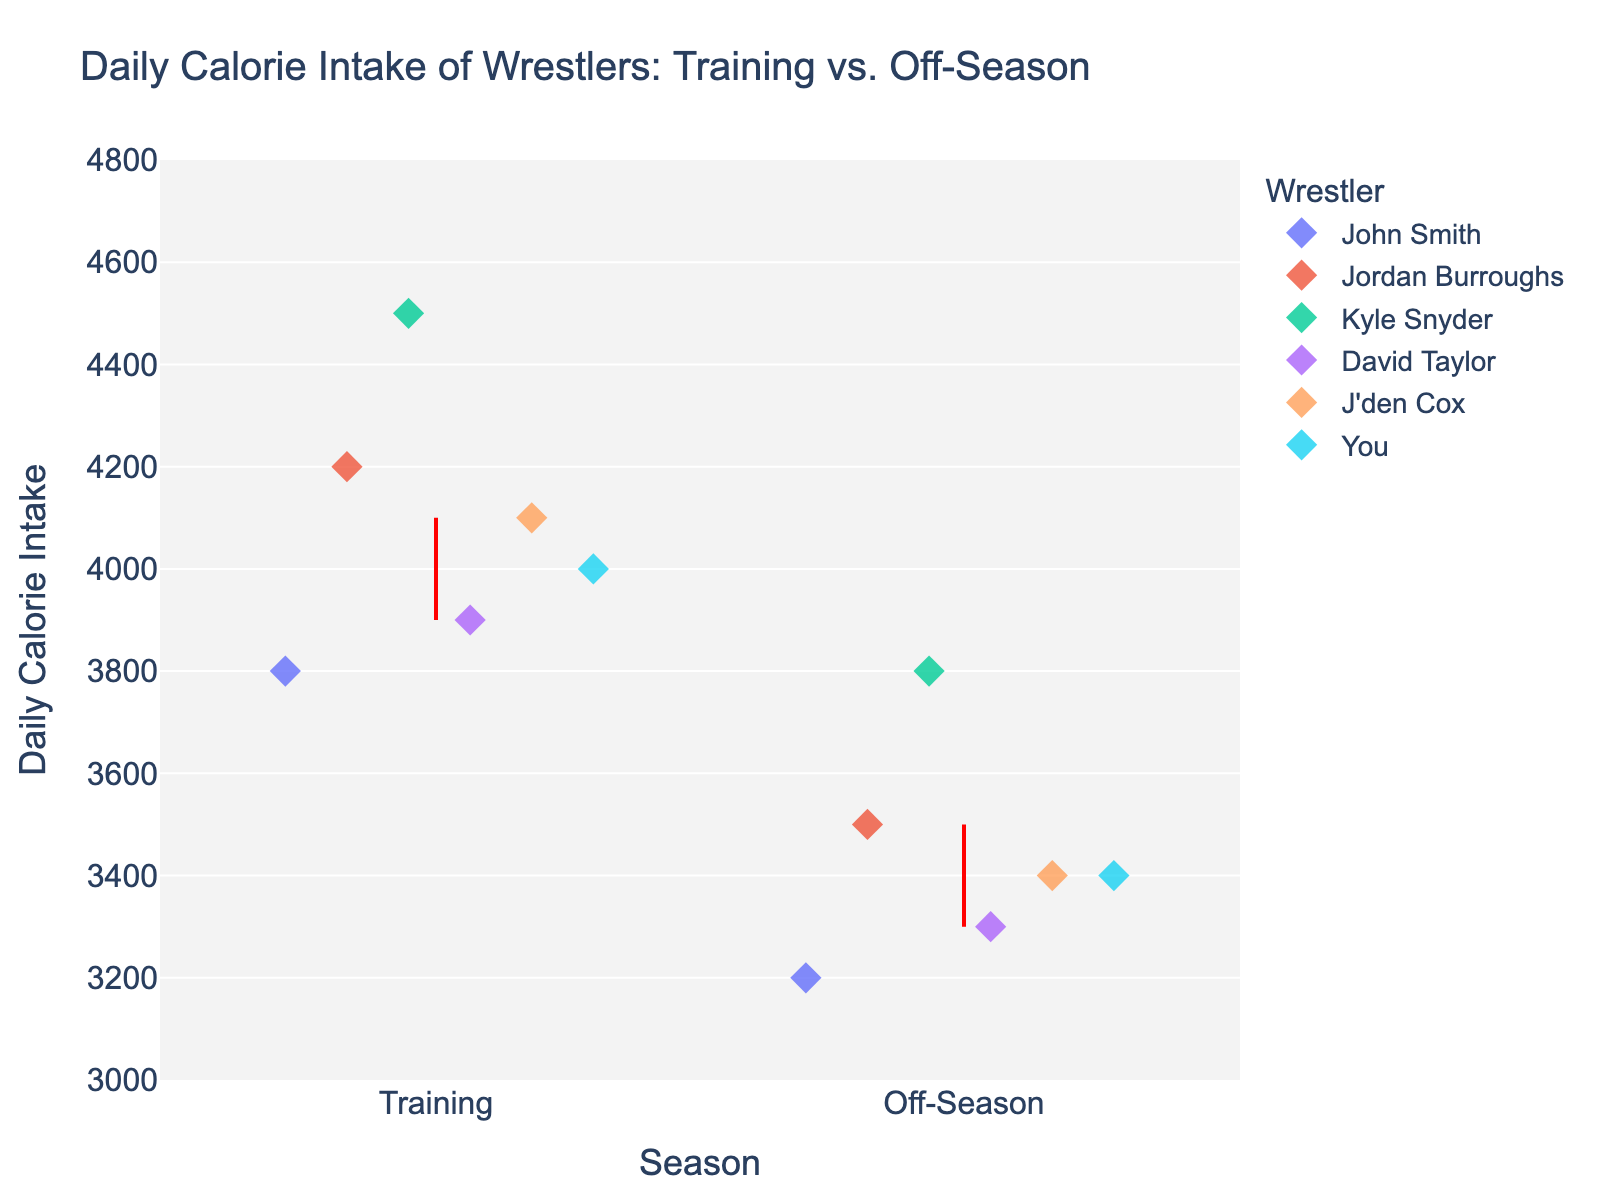How many wrestlers are represented in each Season? The plot shows different data points for each wrestler in both training and off-season. By counting the distinct markers in one season, we can determine the number of wrestlers.
Answer: 6 Which wrestler has the highest daily calorie intake during the training season? Looking at the training season markers, we find the one with the highest position on the y-axis. Kyle Snyder is at the top with 4500 calories.
Answer: Kyle Snyder What is the average daily calorie intake during the training season? Add the daily calorie intake for all wrestlers during the training season (3800 + 4200 + 4500 + 3900 + 4100 + 4000) and then divide by the number of wrestlers (6). The calculation is (3800 + 4200 + 4500 + 3900 + 4100 + 4000) / 6 = 4083.33.
Answer: 4083.33 By how much does your daily calorie intake change from training to off-season? Identify and subtract your calorie intake during the training season and off-season. You have 4000 during training and 3400 during off-season, so the difference is 4000 - 3400 = 600.
Answer: 600 Which season has a greater variation in daily calorie intake among wrestlers? Observe the spread of the markers along the y-axis for each season. The training season has daily calorie intakes ranging from 3800 to 4500, while the off-season ranges from 3200 to 3800, indicating more variation in the training season.
Answer: Training season How many additional calories does Kyle Snyder consume in the training season compared to the off-season? Identify Kyle Snyder's calorie intakes for training (4500) and off-season (3800), then subtract the off-season intake from the training season intake: 4500 - 3800 = 700.
Answer: 700 Who has the smallest decrease in daily calorie intake from training to off-season? Calculate the decrease for each wrestler: 
John Smith: 3800 - 3200 = 600, 
Jordan Burroughs: 4200 - 3500 = 700, 
Kyle Snyder: 4500 - 3800 = 700, 
David Taylor: 3900 - 3300 = 600, 
J'den Cox: 4100 - 3400 = 700, 
You: 4000 - 3400 = 600. The smallest decrease is 600 calories, shared by John Smith, David Taylor, and yourself.
Answer: John Smith, David Taylor, and You What is the difference between the highest and lowest daily calorie intake during the off-season? Find the maximum and minimum values for the off-season: highest is 3800 (Kyle Snyder), lowest is 3200 (John Smith). The difference is 3800 - 3200 = 600.
Answer: 600 Is there any wrestler who has the same daily calorie intake in both seasons? By observing the plot, none of the wrestlers have their markers at the same y-axis level across training and off-season; all wrestlers show a change in intake.
Answer: No 